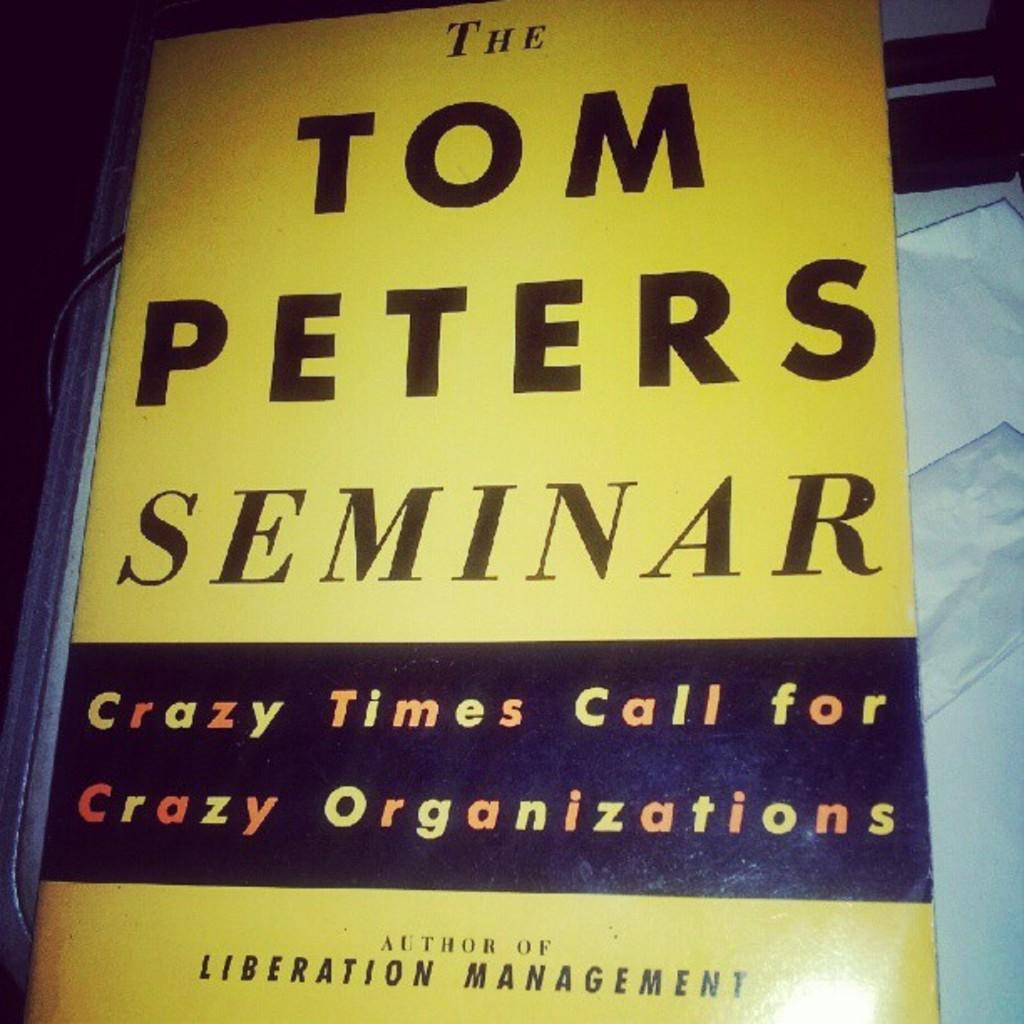<image>
Write a terse but informative summary of the picture. A book or poster that says The Tom Peters Seminar, Crazy Times Call for Crazy Organizations 